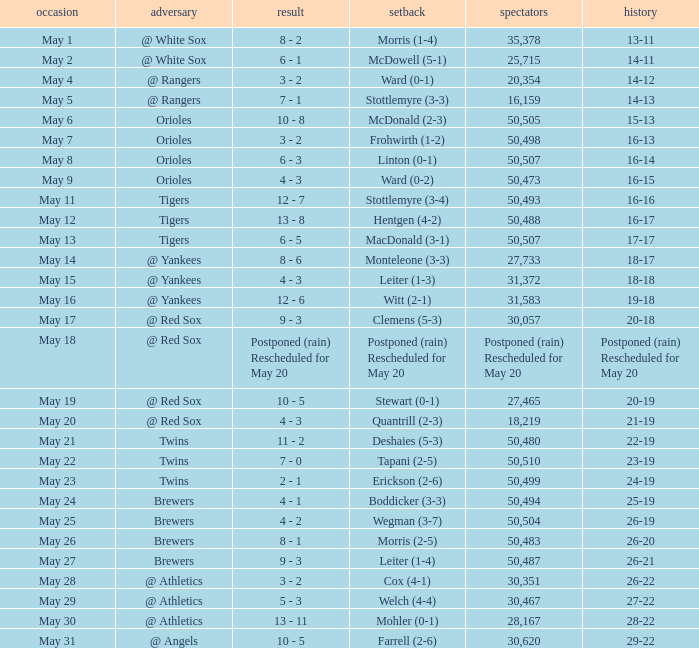What was the score of the game played on May 9? 4 - 3. 